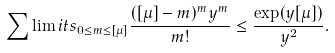<formula> <loc_0><loc_0><loc_500><loc_500>\sum \lim i t s _ { 0 \leq m \leq [ \mu ] } \frac { ( [ \mu ] - m ) ^ { m } y ^ { m } } { m ! } \leq \frac { \exp ( y [ \mu ] ) } { y ^ { 2 } } .</formula> 